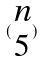Convert formula to latex. <formula><loc_0><loc_0><loc_500><loc_500>( \begin{matrix} n \\ 5 \end{matrix} )</formula> 